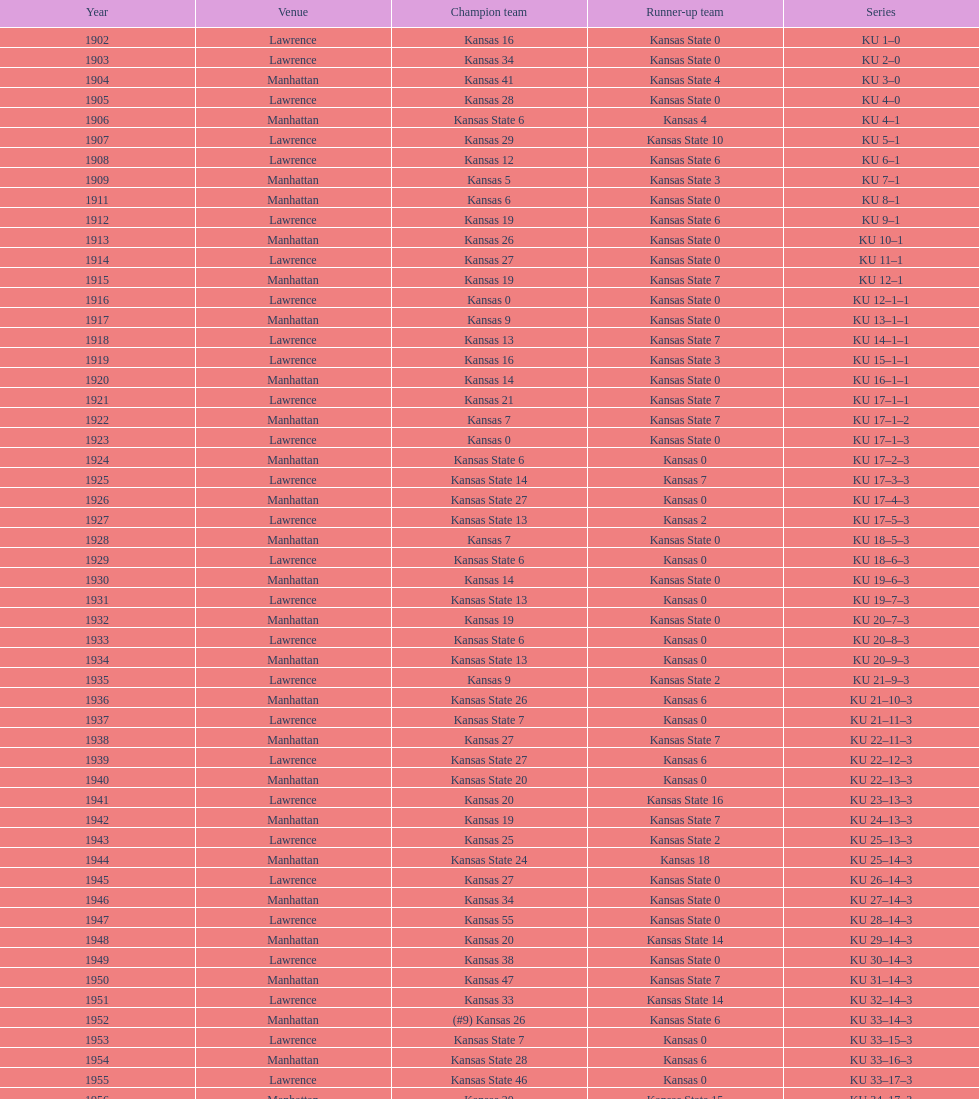How many times did kansas and kansas state play in lawrence from 1902-1968? 34. 